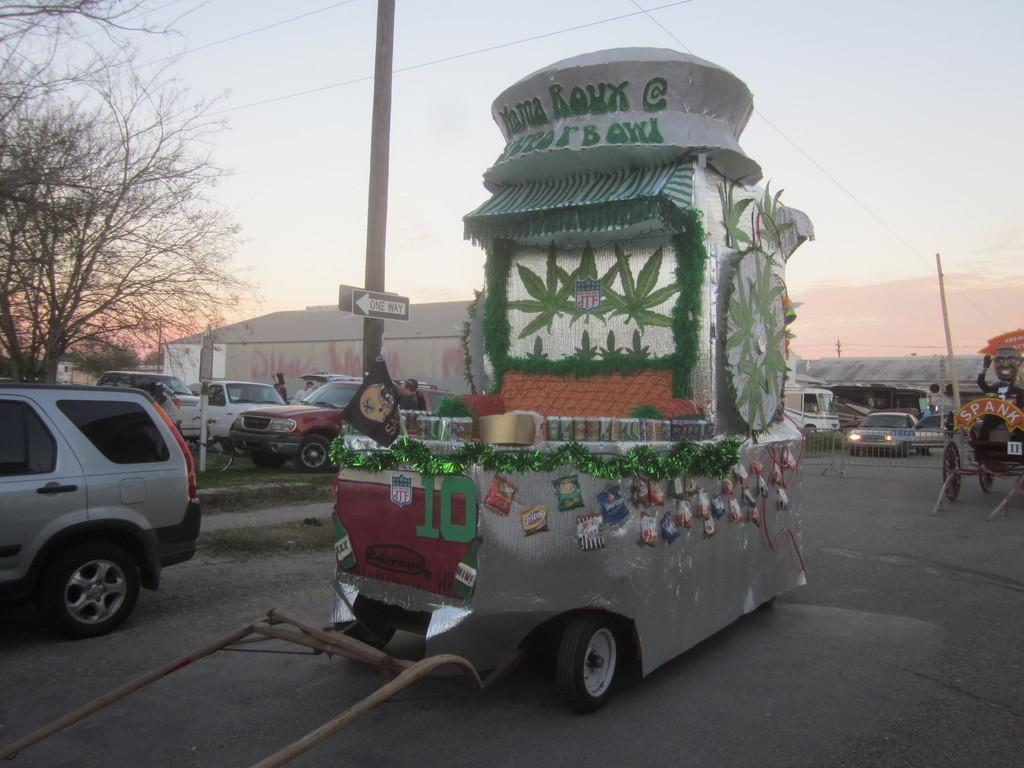What can be seen on the road in the image? There are vehicles on the road in the image. What is present near the road in the image? There is a railing and poles in the image. What is attached to the poles in the image? Wires are present in the image, and they are attached to the poles. What is located on one of the poles in the image? There is a sign board on a pole in the image. What type of natural elements can be seen in the image? Trees are visible in the image. What can be seen in the background of the image? There are buildings and the sky visible in the background of the image. Where is the volcano located in the image? There is no volcano present in the image. What type of jewelry is being discussed in the meeting in the image? There is no meeting or jewelry present in the image. 